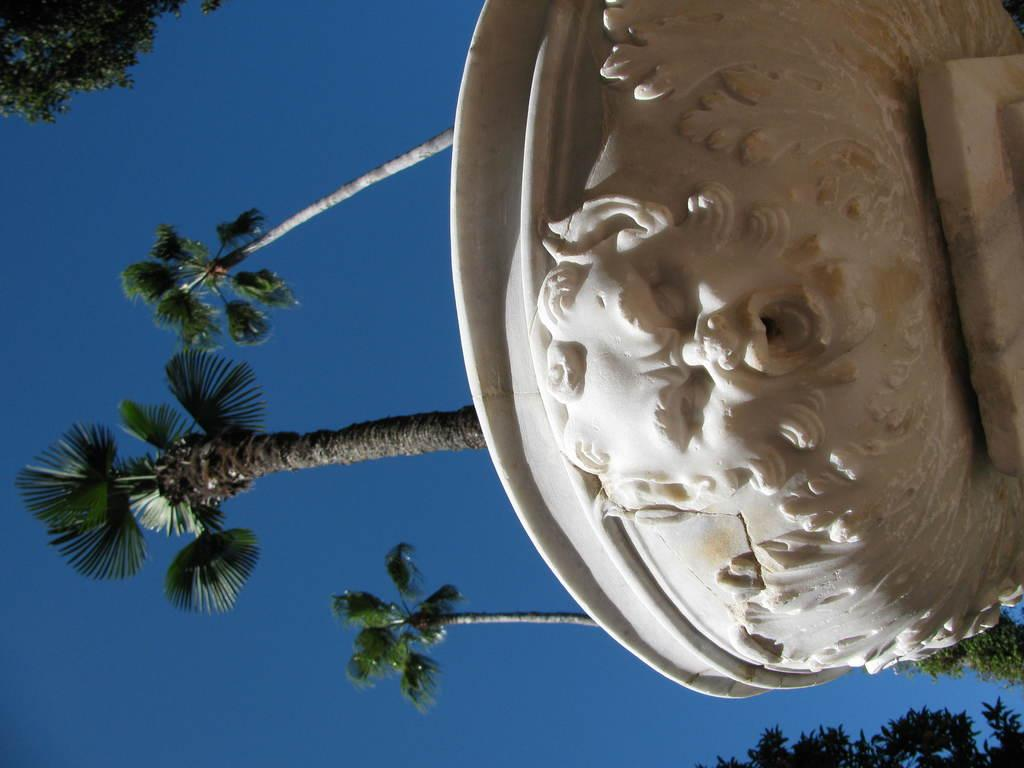What object is the main focus of the image? There is a pot in the image. What color is the pot? The pot is white. What is on top of the pot? There is a statue on the pot. What can be seen in the background of the image? There are trees and the sky visible in the background of the image. What color are the trees? The trees are green. What color is the sky? The sky is blue. What time of day is it in the image, and is there a cat visible? The time of day cannot be determined from the image, and there is no cat visible. What type of fruit is the cat eating in the image? There is no cat or fruit present in the image. 